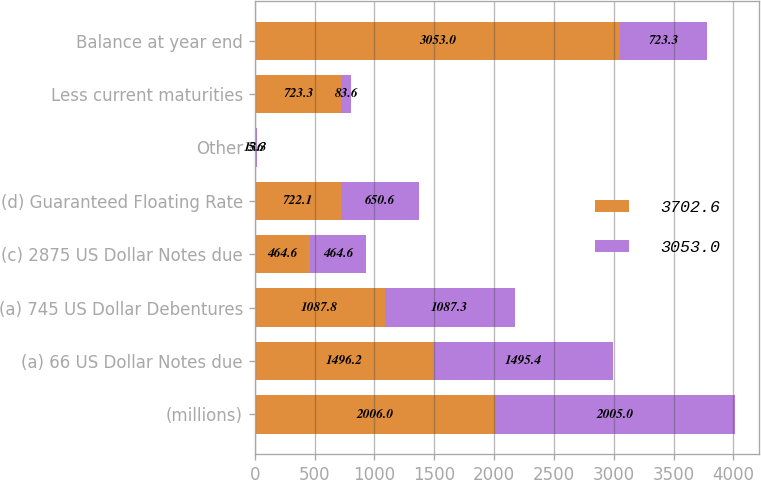<chart> <loc_0><loc_0><loc_500><loc_500><stacked_bar_chart><ecel><fcel>(millions)<fcel>(a) 66 US Dollar Notes due<fcel>(a) 745 US Dollar Debentures<fcel>(c) 2875 US Dollar Notes due<fcel>(d) Guaranteed Floating Rate<fcel>Other<fcel>Less current maturities<fcel>Balance at year end<nl><fcel>3702.6<fcel>2006<fcel>1496.2<fcel>1087.8<fcel>464.6<fcel>722.1<fcel>5.6<fcel>723.3<fcel>3053<nl><fcel>3053<fcel>2005<fcel>1495.4<fcel>1087.3<fcel>464.6<fcel>650.6<fcel>13.3<fcel>83.6<fcel>723.3<nl></chart> 